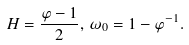Convert formula to latex. <formula><loc_0><loc_0><loc_500><loc_500>H = \frac { \varphi - 1 } { 2 } , \, \omega _ { 0 } = 1 - \varphi ^ { - 1 } .</formula> 